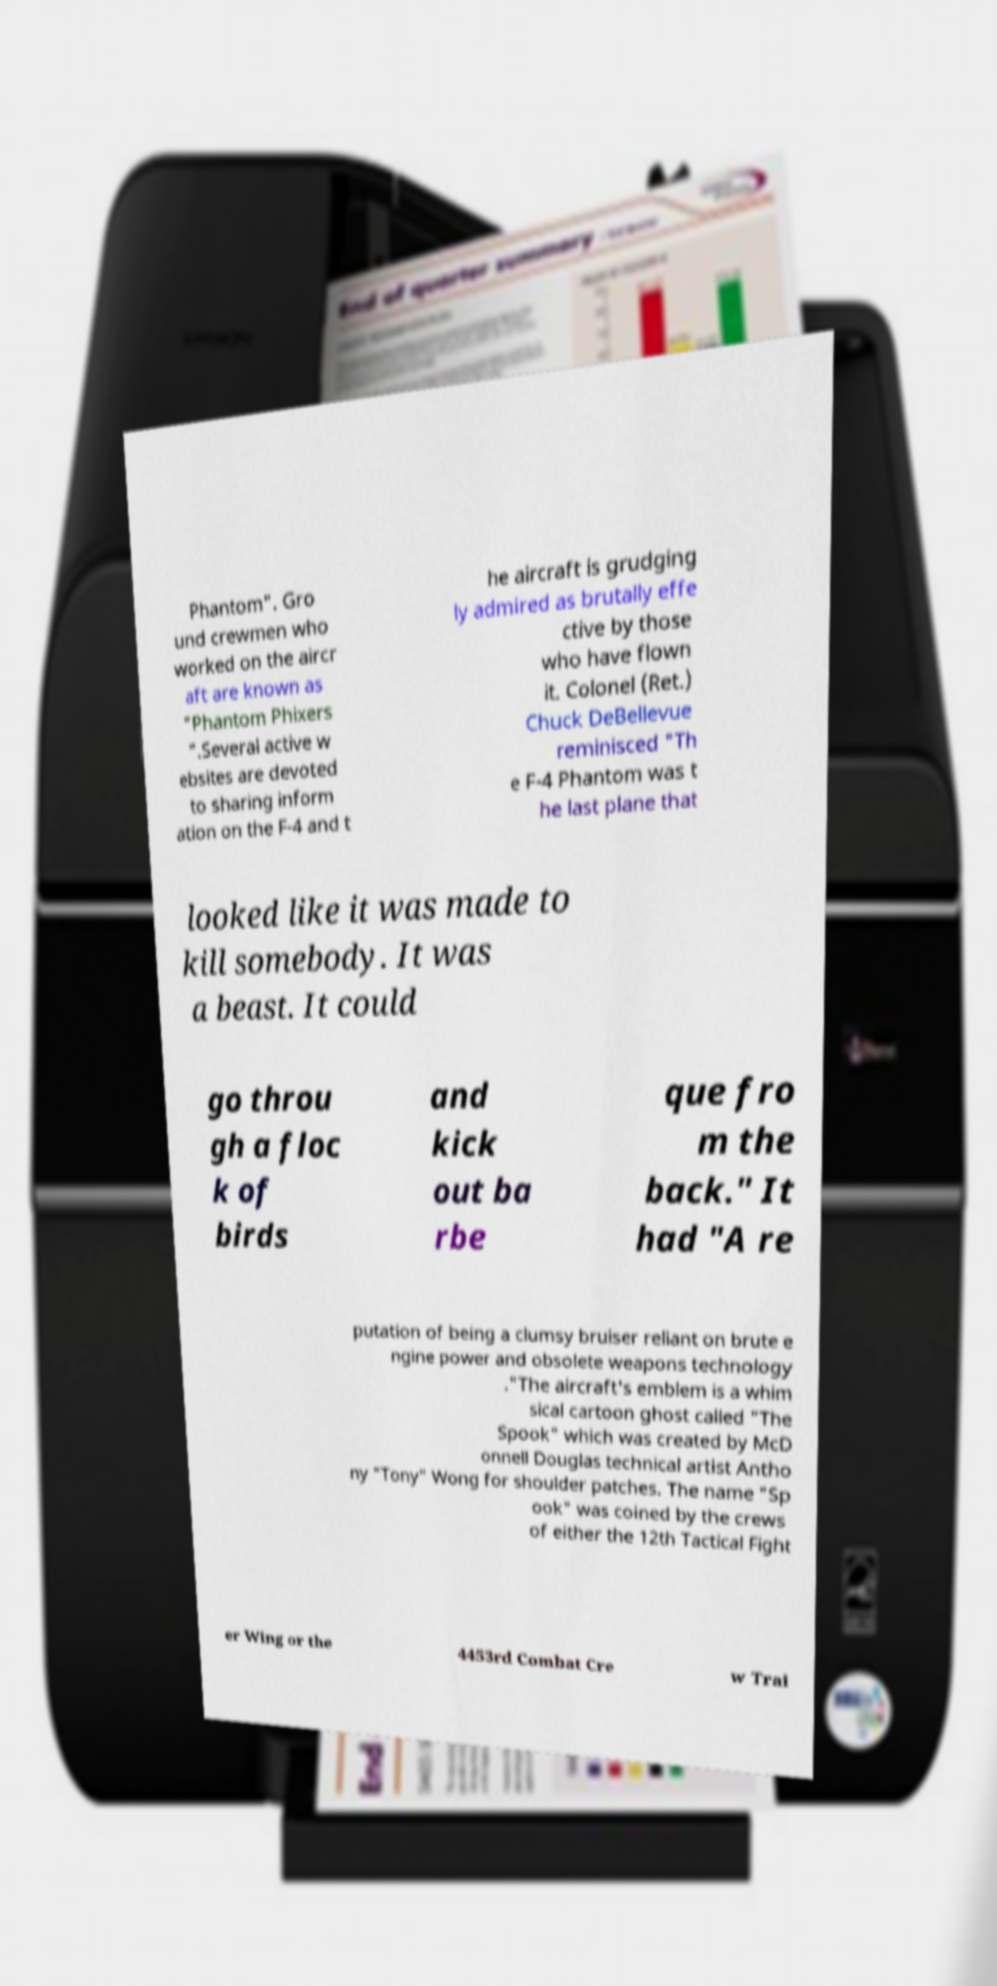What messages or text are displayed in this image? I need them in a readable, typed format. Phantom". Gro und crewmen who worked on the aircr aft are known as "Phantom Phixers ".Several active w ebsites are devoted to sharing inform ation on the F-4 and t he aircraft is grudging ly admired as brutally effe ctive by those who have flown it. Colonel (Ret.) Chuck DeBellevue reminisced "Th e F-4 Phantom was t he last plane that looked like it was made to kill somebody. It was a beast. It could go throu gh a floc k of birds and kick out ba rbe que fro m the back." It had "A re putation of being a clumsy bruiser reliant on brute e ngine power and obsolete weapons technology ."The aircraft's emblem is a whim sical cartoon ghost called "The Spook" which was created by McD onnell Douglas technical artist Antho ny "Tony" Wong for shoulder patches. The name "Sp ook" was coined by the crews of either the 12th Tactical Fight er Wing or the 4453rd Combat Cre w Trai 